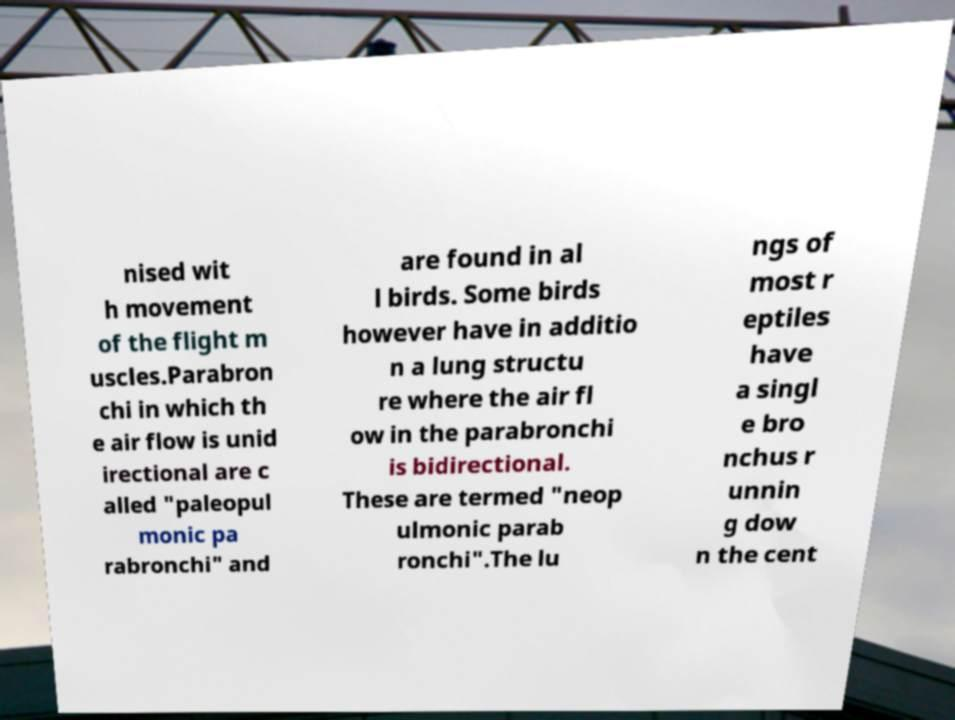For documentation purposes, I need the text within this image transcribed. Could you provide that? nised wit h movement of the flight m uscles.Parabron chi in which th e air flow is unid irectional are c alled "paleopul monic pa rabronchi" and are found in al l birds. Some birds however have in additio n a lung structu re where the air fl ow in the parabronchi is bidirectional. These are termed "neop ulmonic parab ronchi".The lu ngs of most r eptiles have a singl e bro nchus r unnin g dow n the cent 